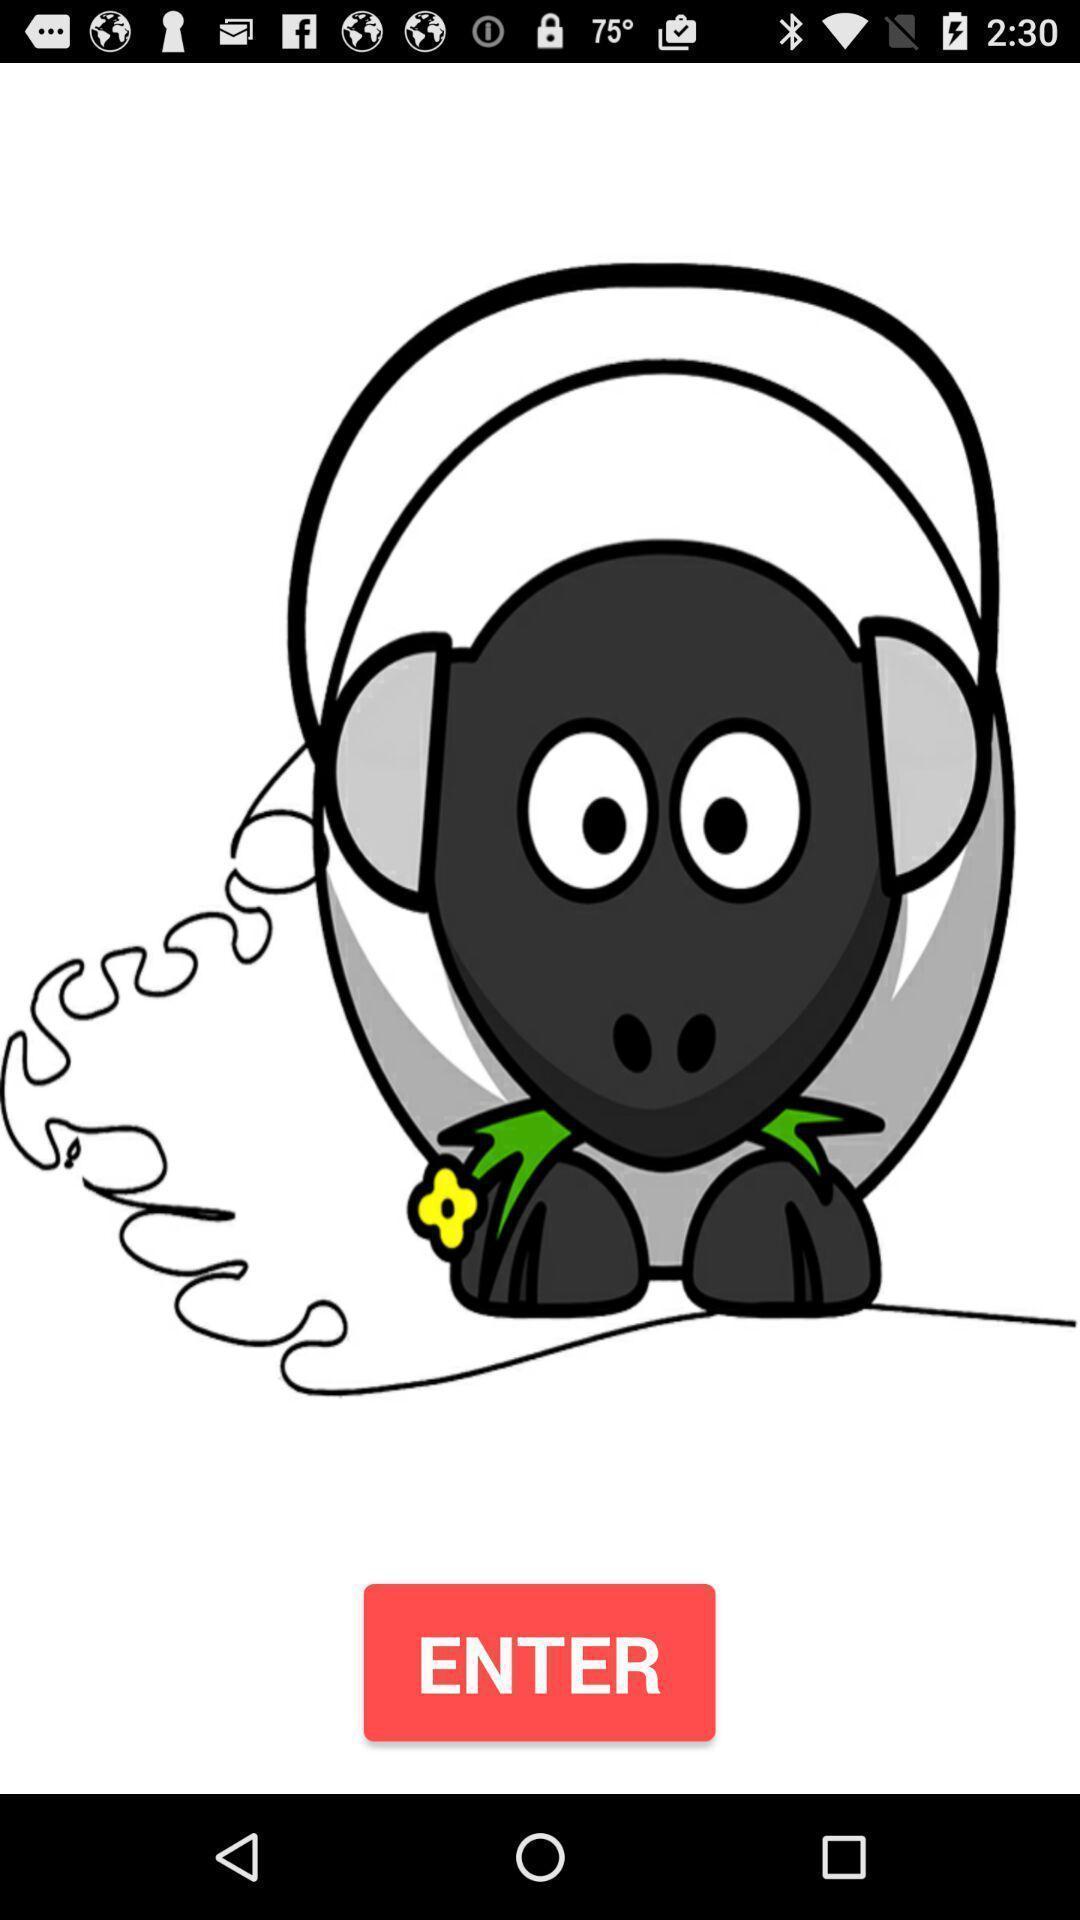Provide a detailed account of this screenshot. Page displaying with a image and option to enter. 